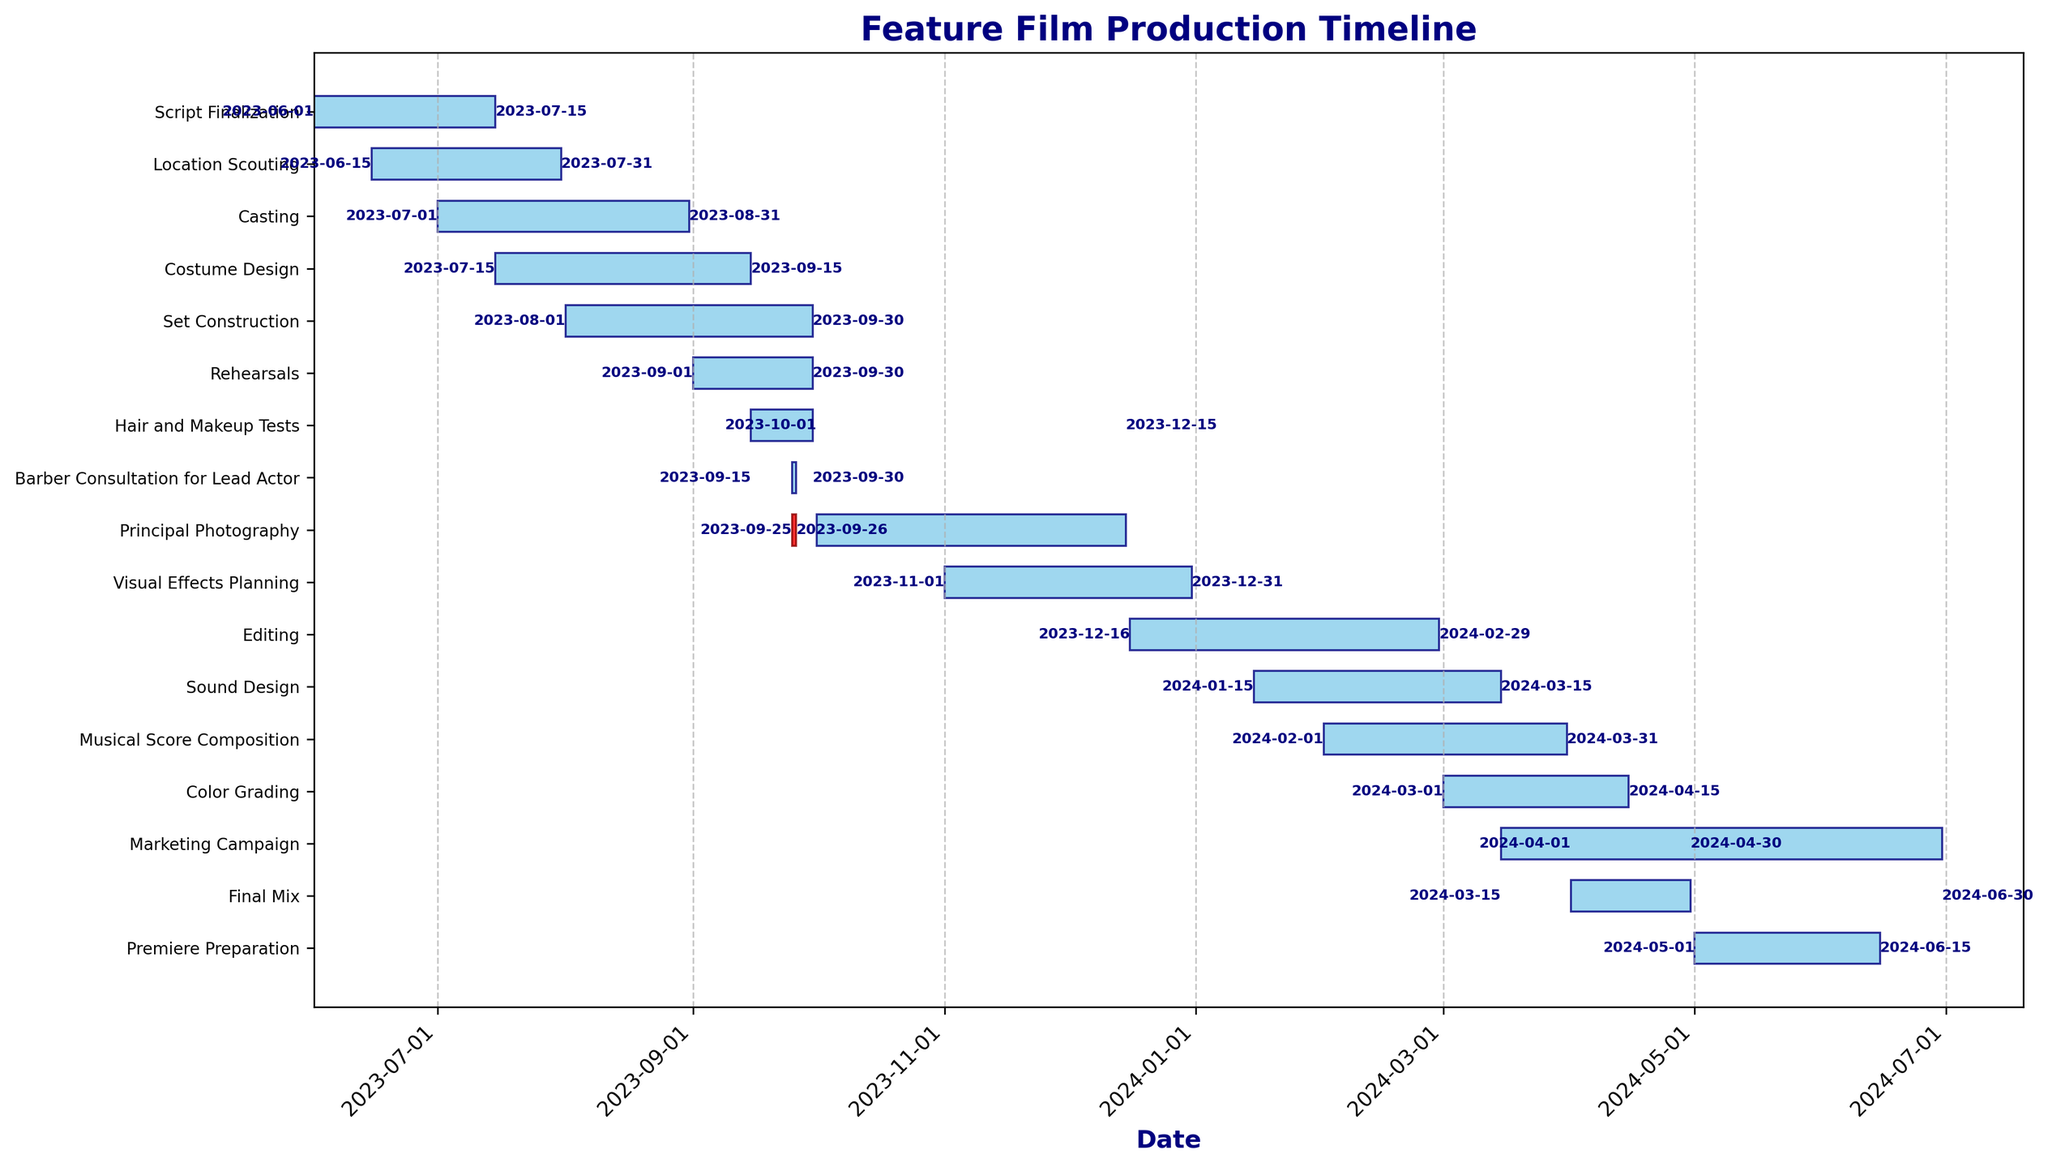what is the title of the Gantt chart? The title of the Gantt chart is usually located at the top of the chart. In this case, the title is clearly stated at the top in bold.
Answer: Feature Film Production Timeline What are the start and end dates for the 'Principal Photography' task? Locate the 'Principal Photography' task on the y-axis and observe the horizontal bar representing its duration. The start and end dates are marked at the ends of the bar.
Answer: 2023-10-01 to 2023-12-15 Which task has the earliest start date? Compare the start dates of all the tasks and identify the one that begins first. This requires reading the start dates from the leftmost point of each horizontal bar.
Answer: Script Finalization How many days does the 'Barber Consultation for Lead Actor' task span? Check the start and end dates for the 'Barber Consultation for Lead Actor,' calculate the difference between these dates to determine the task duration. This task spans over one day from 2023-09-25 to 2023-09-26.
Answer: 1 day Which task ends the latest, and what is its end date? Compare the end dates of all tasks, locating the one with the latest end date at the rightmost point of its horizontal bar.
Answer: Marketing Campaign, 2024-06-30 What is the total duration of the pre-production phase spanning from the start of 'Script Finalization' to the end of 'Rehearsals'? Identify the start date of 'Script Finalization' and the end date of 'Rehearsals', and calculate the total duration between these two dates. The pre-production phase runs from 2023-06-01 to 2023-09-30.
Answer: 121 days How long is the time gap between the end of 'Set Construction' and the start of 'Principal Photography'? Note the end date of 'Set Construction' and the start date of 'Principal Photography'. Calculate the number of days between these two dates. 'Set Construction' ends on 2023-09-30 and 'Principal Photography' starts on 2023-10-01, with no gap between them.
Answer: 0 days Which tasks are overlapping with the 'Casting' task? Identify the tasks whose date ranges overlap with the date range of 'Casting' from 2023-07-01 to 2023-08-31. These tasks include 'Script Finalization', 'Location Scouting', and 'Costume Design'.
Answer: Script Finalization, Location Scouting, Costume Design How many tasks are there in total? Count the horizontal bars representing different tasks in the Gantt chart to determine the total number. Each task has a corresponding bar in the chart.
Answer: 16 tasks Is the 'Hair and Makeup Tests' task scheduled before or after the 'Set Construction' task? Compare the start date of 'Hair and Makeup Tests' with the start date of 'Set Construction'. 'Hair and Makeup Tests' starts on 2023-09-15, which is after the 'Set Construction' that starts on 2023-08-01.
Answer: After 